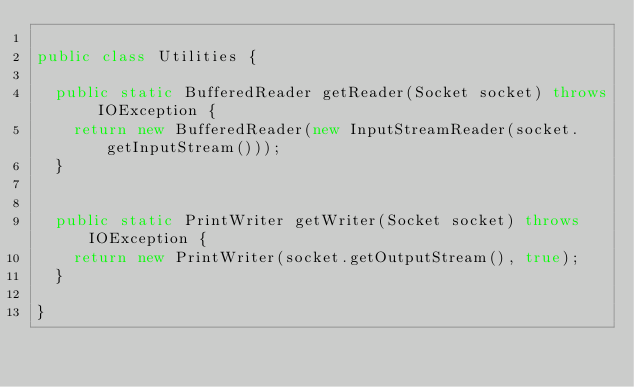<code> <loc_0><loc_0><loc_500><loc_500><_Java_>
public class Utilities {

	public static BufferedReader getReader(Socket socket) throws IOException {
		return new BufferedReader(new InputStreamReader(socket.getInputStream()));
	}


	public static PrintWriter getWriter(Socket socket) throws IOException {
		return new PrintWriter(socket.getOutputStream(), true);
	}

}
</code> 